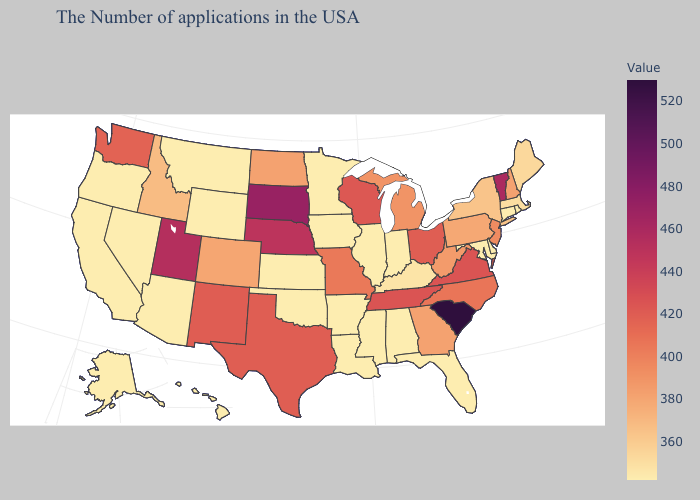Which states have the lowest value in the USA?
Write a very short answer. Rhode Island, Connecticut, Delaware, Maryland, Florida, Indiana, Alabama, Illinois, Mississippi, Louisiana, Arkansas, Minnesota, Iowa, Kansas, Oklahoma, Wyoming, Montana, Arizona, Nevada, California, Oregon, Alaska, Hawaii. Does South Carolina have the highest value in the USA?
Answer briefly. Yes. Among the states that border Utah , which have the lowest value?
Give a very brief answer. Wyoming, Arizona, Nevada. Is the legend a continuous bar?
Keep it brief. Yes. 